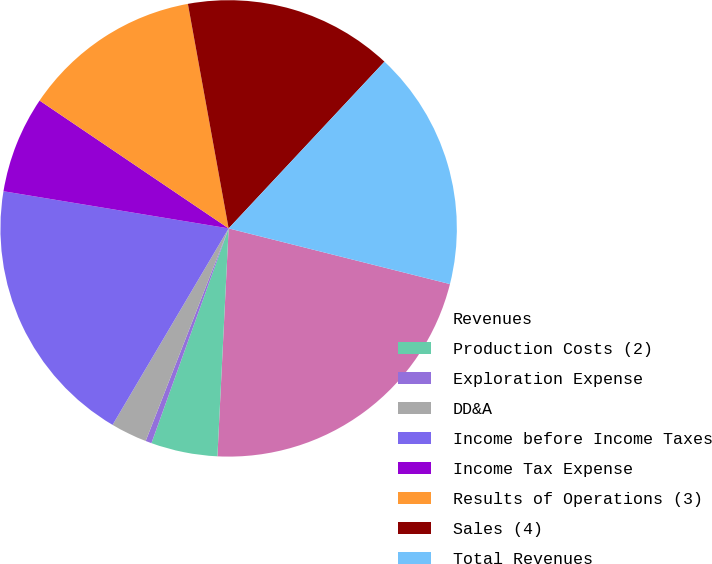Convert chart to OTSL. <chart><loc_0><loc_0><loc_500><loc_500><pie_chart><fcel>Revenues<fcel>Production Costs (2)<fcel>Exploration Expense<fcel>DD&A<fcel>Income before Income Taxes<fcel>Income Tax Expense<fcel>Results of Operations (3)<fcel>Sales (4)<fcel>Total Revenues<nl><fcel>21.86%<fcel>4.71%<fcel>0.43%<fcel>2.57%<fcel>19.11%<fcel>6.86%<fcel>12.68%<fcel>14.82%<fcel>16.96%<nl></chart> 